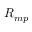Convert formula to latex. <formula><loc_0><loc_0><loc_500><loc_500>{ R } _ { m p }</formula> 